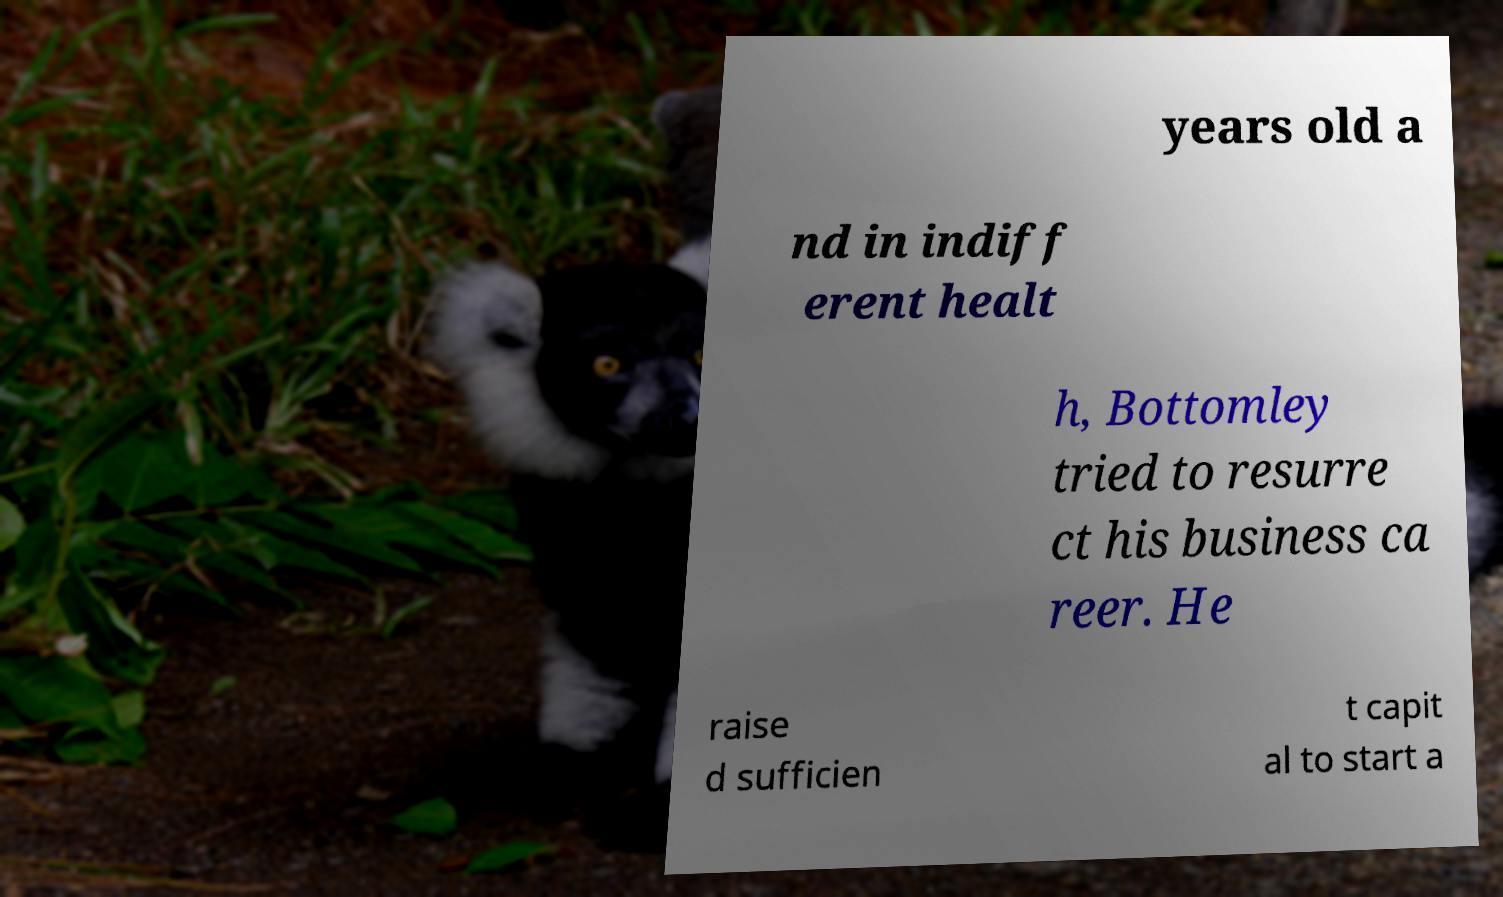Could you assist in decoding the text presented in this image and type it out clearly? years old a nd in indiff erent healt h, Bottomley tried to resurre ct his business ca reer. He raise d sufficien t capit al to start a 